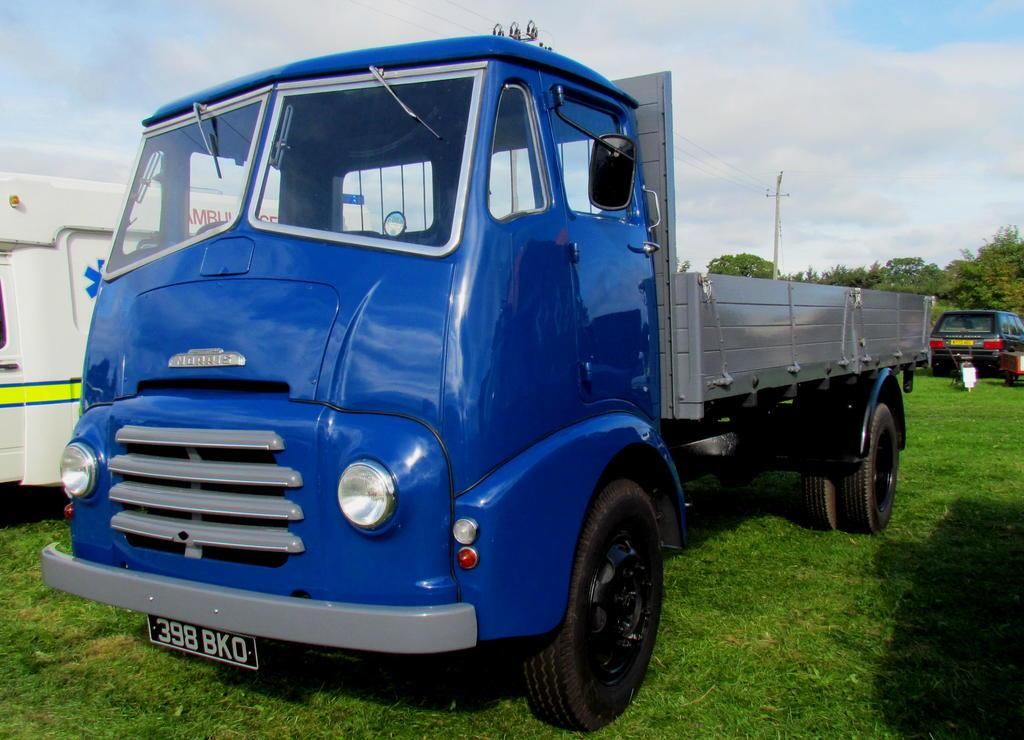What is the main vehicle in the center of the image? There is a truck in the center of the image. What other vehicle can be seen on the right side of the image? There is a car on the right side of the image. What type of emergency vehicle is visible in the background of the image? There is an ambulance in the background of the image. What type of natural scenery is visible in the background of the image? There are trees in the background of the image. What else can be seen in the background of the image? There is a pole with wires in the background of the image. How much payment is required to use the ant in the image? There is no ant present in the image, and therefore no payment is required for its use. What type of blood is visible in the image? There is no blood visible in the image. 